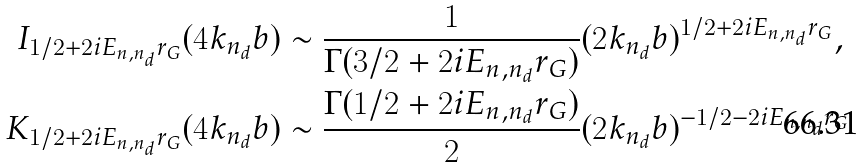<formula> <loc_0><loc_0><loc_500><loc_500>I _ { 1 / 2 + 2 i E _ { n , n _ { d } } r _ { G } } ( 4 k _ { n _ { d } } b ) & \sim \frac { 1 } { \Gamma ( 3 / 2 + 2 i E _ { n , n _ { d } } r _ { G } ) } ( 2 k _ { n _ { d } } b ) ^ { 1 / 2 + 2 i E _ { n , n _ { d } } r _ { G } } , \\ K _ { 1 / 2 + 2 i E _ { n , n _ { d } } r _ { G } } ( 4 k _ { n _ { d } } b ) & \sim \frac { \Gamma ( 1 / 2 + 2 i E _ { n , n _ { d } } r _ { G } ) } { 2 } ( 2 k _ { n _ { d } } b ) ^ { - 1 / 2 - 2 i E _ { n , n _ { d } } r _ { G } }</formula> 